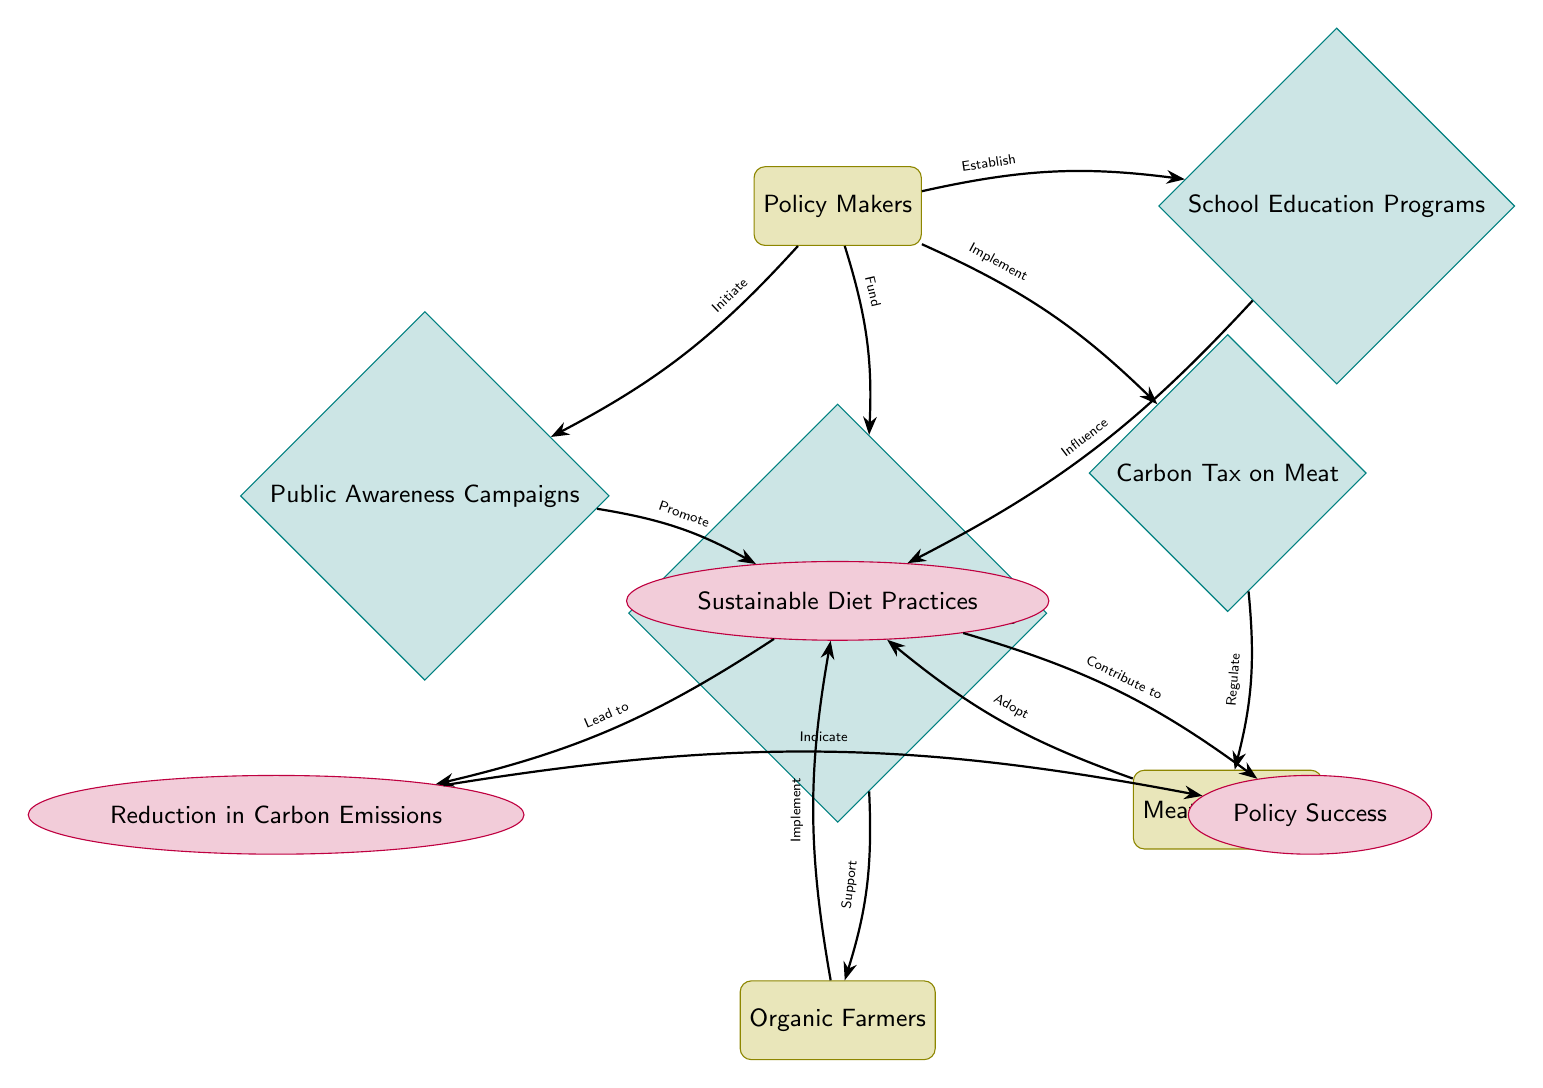What outcomes are expected from sustainable diet practices? The diagram shows two outcomes linked to sustainable diet practices: "Reduction in Carbon Emissions" and "Policy Success." These outcomes are placed below sustainable diet practices, indicating they stem from the implementation of such practices.
Answer: Reduction in Carbon Emissions, Policy Success How many interventions are initiated by policy makers? The diagram highlights four interventions initiated by policy makers: "Public Awareness Campaigns," "Subsidies for Sustainable Farming," "Carbon Tax on Meat," and "School Education Programs." Each intervention is connected to the policy makers through an arrow labeled with the action they take. Counting these interventions gives a total of four.
Answer: 4 Which actor receives support from subsidies for sustainable farming? The diagram connects "Subsidies for Sustainable Farming" to "Organic Farmers" through an edge labeled "Support." This indicates that the farmers are the recipients of support from this specific intervention.
Answer: Organic Farmers What is the relationship between emissions and policy success? The diagram indicates that "Reduction in Carbon Emissions" leads to "Policy Success." This is demonstrated through the arrow connecting these two outcomes, suggesting that a reduction in emissions is a contributing factor to the overall success of the policies implemented.
Answer: Lead to Which intervention influences practices through education? The diagram shows that "School Education Programs" influence "Sustainable Diet Practices" as indicated by the arrow labeled "Influence." This connection signifies that educational initiatives play a role in changing dietary behaviors towards sustainability.
Answer: School Education Programs How do meat producers interact with sustainable diet practices? The diagram depicts the relationship between "Meat Producers" and "Sustainable Diet Practices" via the edge labeled "Adopt." This suggests that meat producers have a role in shifting towards sustainable practices, which affects their operations and potentially their environmental impact.
Answer: Adopt What role do public awareness campaigns have in promoting sustainable diets? The diagram shows that "Public Awareness Campaigns" promote "Sustainable Diet Practices." This is represented by an arrow that indicates a direct relationship where raising awareness contributes to the adoption of sustainable dietary habits among the population.
Answer: Promote What is the main actor in the diagram? The main actor in the diagram is "Policy Makers," as they initiate all interventions depicted. The policy makers are positioned at the top of the diagram, from where various arrows leading to interventions and outcomes originate.
Answer: Policy Makers 